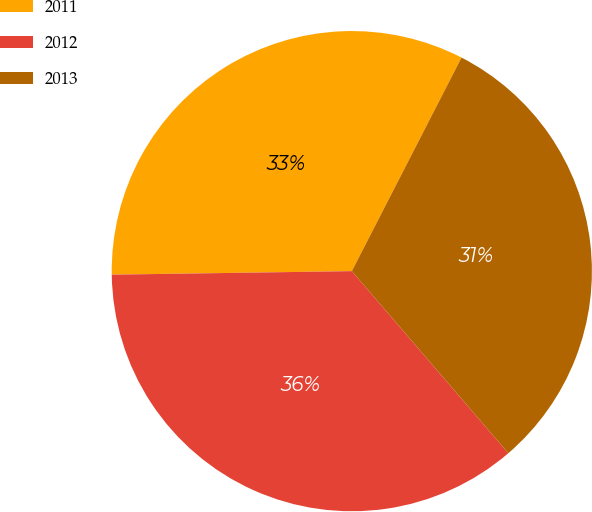Convert chart. <chart><loc_0><loc_0><loc_500><loc_500><pie_chart><fcel>2011<fcel>2012<fcel>2013<nl><fcel>32.79%<fcel>36.07%<fcel>31.15%<nl></chart> 